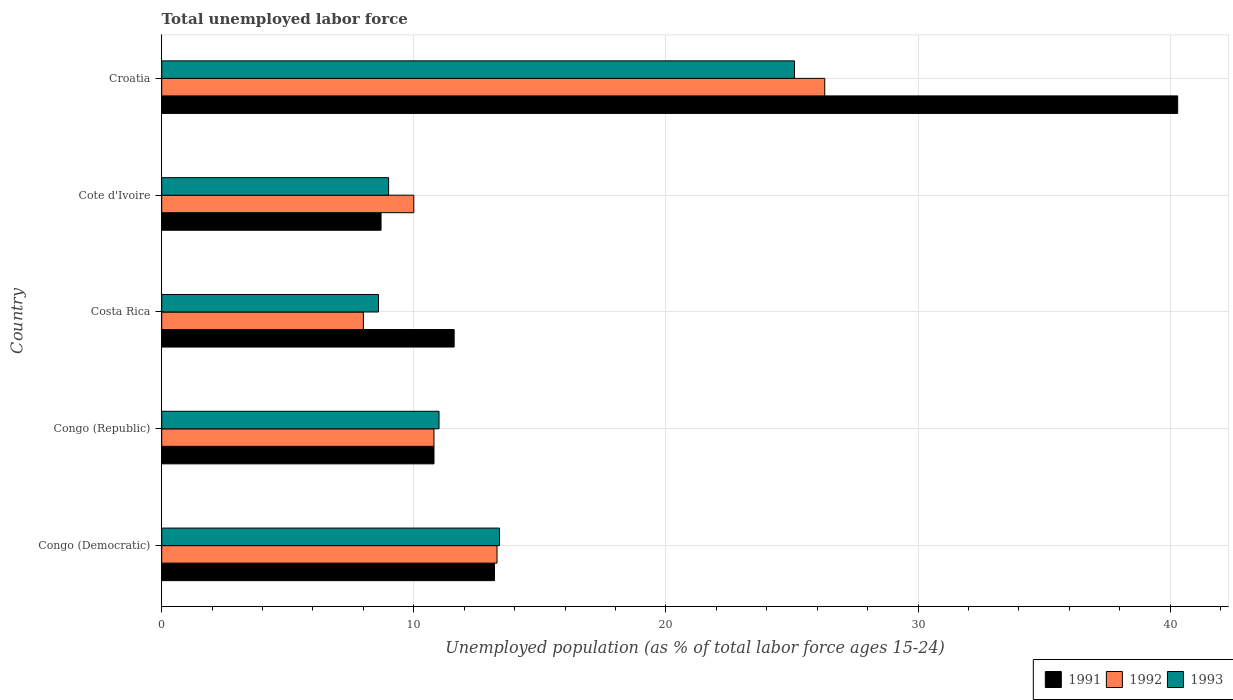How many different coloured bars are there?
Offer a terse response. 3. Are the number of bars on each tick of the Y-axis equal?
Keep it short and to the point. Yes. How many bars are there on the 4th tick from the top?
Your response must be concise. 3. How many bars are there on the 2nd tick from the bottom?
Ensure brevity in your answer.  3. What is the label of the 4th group of bars from the top?
Give a very brief answer. Congo (Republic). In how many cases, is the number of bars for a given country not equal to the number of legend labels?
Your answer should be very brief. 0. What is the percentage of unemployed population in in 1992 in Congo (Republic)?
Make the answer very short. 10.8. Across all countries, what is the maximum percentage of unemployed population in in 1992?
Your answer should be compact. 26.3. Across all countries, what is the minimum percentage of unemployed population in in 1992?
Keep it short and to the point. 8. In which country was the percentage of unemployed population in in 1993 maximum?
Provide a succinct answer. Croatia. In which country was the percentage of unemployed population in in 1991 minimum?
Your answer should be very brief. Cote d'Ivoire. What is the total percentage of unemployed population in in 1991 in the graph?
Make the answer very short. 84.6. What is the difference between the percentage of unemployed population in in 1992 in Costa Rica and that in Croatia?
Give a very brief answer. -18.3. What is the difference between the percentage of unemployed population in in 1991 in Cote d'Ivoire and the percentage of unemployed population in in 1993 in Congo (Democratic)?
Offer a very short reply. -4.7. What is the average percentage of unemployed population in in 1992 per country?
Offer a terse response. 13.68. What is the difference between the percentage of unemployed population in in 1991 and percentage of unemployed population in in 1992 in Congo (Democratic)?
Ensure brevity in your answer.  -0.1. What is the ratio of the percentage of unemployed population in in 1992 in Congo (Republic) to that in Cote d'Ivoire?
Your answer should be compact. 1.08. Is the percentage of unemployed population in in 1992 in Congo (Democratic) less than that in Cote d'Ivoire?
Give a very brief answer. No. What is the difference between the highest and the second highest percentage of unemployed population in in 1992?
Your answer should be very brief. 13. What is the difference between the highest and the lowest percentage of unemployed population in in 1993?
Your answer should be compact. 16.5. What does the 2nd bar from the bottom in Croatia represents?
Offer a terse response. 1992. What is the difference between two consecutive major ticks on the X-axis?
Provide a short and direct response. 10. Are the values on the major ticks of X-axis written in scientific E-notation?
Your answer should be compact. No. Where does the legend appear in the graph?
Your answer should be very brief. Bottom right. What is the title of the graph?
Provide a short and direct response. Total unemployed labor force. Does "2013" appear as one of the legend labels in the graph?
Your answer should be very brief. No. What is the label or title of the X-axis?
Your answer should be compact. Unemployed population (as % of total labor force ages 15-24). What is the label or title of the Y-axis?
Offer a terse response. Country. What is the Unemployed population (as % of total labor force ages 15-24) in 1991 in Congo (Democratic)?
Provide a succinct answer. 13.2. What is the Unemployed population (as % of total labor force ages 15-24) of 1992 in Congo (Democratic)?
Your response must be concise. 13.3. What is the Unemployed population (as % of total labor force ages 15-24) of 1993 in Congo (Democratic)?
Provide a succinct answer. 13.4. What is the Unemployed population (as % of total labor force ages 15-24) of 1991 in Congo (Republic)?
Your answer should be very brief. 10.8. What is the Unemployed population (as % of total labor force ages 15-24) in 1992 in Congo (Republic)?
Your answer should be very brief. 10.8. What is the Unemployed population (as % of total labor force ages 15-24) in 1991 in Costa Rica?
Your answer should be very brief. 11.6. What is the Unemployed population (as % of total labor force ages 15-24) in 1992 in Costa Rica?
Give a very brief answer. 8. What is the Unemployed population (as % of total labor force ages 15-24) in 1993 in Costa Rica?
Keep it short and to the point. 8.6. What is the Unemployed population (as % of total labor force ages 15-24) of 1991 in Cote d'Ivoire?
Provide a succinct answer. 8.7. What is the Unemployed population (as % of total labor force ages 15-24) in 1991 in Croatia?
Give a very brief answer. 40.3. What is the Unemployed population (as % of total labor force ages 15-24) of 1992 in Croatia?
Provide a succinct answer. 26.3. What is the Unemployed population (as % of total labor force ages 15-24) in 1993 in Croatia?
Make the answer very short. 25.1. Across all countries, what is the maximum Unemployed population (as % of total labor force ages 15-24) of 1991?
Ensure brevity in your answer.  40.3. Across all countries, what is the maximum Unemployed population (as % of total labor force ages 15-24) in 1992?
Give a very brief answer. 26.3. Across all countries, what is the maximum Unemployed population (as % of total labor force ages 15-24) of 1993?
Ensure brevity in your answer.  25.1. Across all countries, what is the minimum Unemployed population (as % of total labor force ages 15-24) of 1991?
Your answer should be very brief. 8.7. Across all countries, what is the minimum Unemployed population (as % of total labor force ages 15-24) in 1993?
Offer a terse response. 8.6. What is the total Unemployed population (as % of total labor force ages 15-24) of 1991 in the graph?
Provide a succinct answer. 84.6. What is the total Unemployed population (as % of total labor force ages 15-24) of 1992 in the graph?
Your response must be concise. 68.4. What is the total Unemployed population (as % of total labor force ages 15-24) of 1993 in the graph?
Your answer should be very brief. 67.1. What is the difference between the Unemployed population (as % of total labor force ages 15-24) of 1992 in Congo (Democratic) and that in Congo (Republic)?
Keep it short and to the point. 2.5. What is the difference between the Unemployed population (as % of total labor force ages 15-24) of 1991 in Congo (Democratic) and that in Costa Rica?
Ensure brevity in your answer.  1.6. What is the difference between the Unemployed population (as % of total labor force ages 15-24) of 1992 in Congo (Democratic) and that in Cote d'Ivoire?
Your answer should be very brief. 3.3. What is the difference between the Unemployed population (as % of total labor force ages 15-24) of 1991 in Congo (Democratic) and that in Croatia?
Ensure brevity in your answer.  -27.1. What is the difference between the Unemployed population (as % of total labor force ages 15-24) of 1992 in Congo (Democratic) and that in Croatia?
Give a very brief answer. -13. What is the difference between the Unemployed population (as % of total labor force ages 15-24) in 1991 in Congo (Republic) and that in Costa Rica?
Make the answer very short. -0.8. What is the difference between the Unemployed population (as % of total labor force ages 15-24) in 1992 in Congo (Republic) and that in Costa Rica?
Your response must be concise. 2.8. What is the difference between the Unemployed population (as % of total labor force ages 15-24) of 1992 in Congo (Republic) and that in Cote d'Ivoire?
Your response must be concise. 0.8. What is the difference between the Unemployed population (as % of total labor force ages 15-24) in 1993 in Congo (Republic) and that in Cote d'Ivoire?
Your answer should be compact. 2. What is the difference between the Unemployed population (as % of total labor force ages 15-24) in 1991 in Congo (Republic) and that in Croatia?
Offer a terse response. -29.5. What is the difference between the Unemployed population (as % of total labor force ages 15-24) in 1992 in Congo (Republic) and that in Croatia?
Offer a very short reply. -15.5. What is the difference between the Unemployed population (as % of total labor force ages 15-24) in 1993 in Congo (Republic) and that in Croatia?
Offer a terse response. -14.1. What is the difference between the Unemployed population (as % of total labor force ages 15-24) in 1991 in Costa Rica and that in Cote d'Ivoire?
Your response must be concise. 2.9. What is the difference between the Unemployed population (as % of total labor force ages 15-24) in 1993 in Costa Rica and that in Cote d'Ivoire?
Your answer should be very brief. -0.4. What is the difference between the Unemployed population (as % of total labor force ages 15-24) in 1991 in Costa Rica and that in Croatia?
Offer a very short reply. -28.7. What is the difference between the Unemployed population (as % of total labor force ages 15-24) in 1992 in Costa Rica and that in Croatia?
Give a very brief answer. -18.3. What is the difference between the Unemployed population (as % of total labor force ages 15-24) in 1993 in Costa Rica and that in Croatia?
Give a very brief answer. -16.5. What is the difference between the Unemployed population (as % of total labor force ages 15-24) of 1991 in Cote d'Ivoire and that in Croatia?
Ensure brevity in your answer.  -31.6. What is the difference between the Unemployed population (as % of total labor force ages 15-24) in 1992 in Cote d'Ivoire and that in Croatia?
Your answer should be compact. -16.3. What is the difference between the Unemployed population (as % of total labor force ages 15-24) of 1993 in Cote d'Ivoire and that in Croatia?
Provide a short and direct response. -16.1. What is the difference between the Unemployed population (as % of total labor force ages 15-24) in 1991 in Congo (Democratic) and the Unemployed population (as % of total labor force ages 15-24) in 1992 in Congo (Republic)?
Keep it short and to the point. 2.4. What is the difference between the Unemployed population (as % of total labor force ages 15-24) in 1991 in Congo (Democratic) and the Unemployed population (as % of total labor force ages 15-24) in 1993 in Congo (Republic)?
Provide a short and direct response. 2.2. What is the difference between the Unemployed population (as % of total labor force ages 15-24) of 1992 in Congo (Democratic) and the Unemployed population (as % of total labor force ages 15-24) of 1993 in Congo (Republic)?
Keep it short and to the point. 2.3. What is the difference between the Unemployed population (as % of total labor force ages 15-24) in 1991 in Congo (Democratic) and the Unemployed population (as % of total labor force ages 15-24) in 1992 in Cote d'Ivoire?
Your answer should be very brief. 3.2. What is the difference between the Unemployed population (as % of total labor force ages 15-24) in 1991 in Congo (Democratic) and the Unemployed population (as % of total labor force ages 15-24) in 1993 in Cote d'Ivoire?
Your answer should be very brief. 4.2. What is the difference between the Unemployed population (as % of total labor force ages 15-24) of 1991 in Congo (Democratic) and the Unemployed population (as % of total labor force ages 15-24) of 1992 in Croatia?
Ensure brevity in your answer.  -13.1. What is the difference between the Unemployed population (as % of total labor force ages 15-24) in 1992 in Congo (Democratic) and the Unemployed population (as % of total labor force ages 15-24) in 1993 in Croatia?
Provide a short and direct response. -11.8. What is the difference between the Unemployed population (as % of total labor force ages 15-24) in 1991 in Congo (Republic) and the Unemployed population (as % of total labor force ages 15-24) in 1992 in Costa Rica?
Offer a very short reply. 2.8. What is the difference between the Unemployed population (as % of total labor force ages 15-24) in 1991 in Congo (Republic) and the Unemployed population (as % of total labor force ages 15-24) in 1992 in Cote d'Ivoire?
Make the answer very short. 0.8. What is the difference between the Unemployed population (as % of total labor force ages 15-24) of 1992 in Congo (Republic) and the Unemployed population (as % of total labor force ages 15-24) of 1993 in Cote d'Ivoire?
Make the answer very short. 1.8. What is the difference between the Unemployed population (as % of total labor force ages 15-24) in 1991 in Congo (Republic) and the Unemployed population (as % of total labor force ages 15-24) in 1992 in Croatia?
Your response must be concise. -15.5. What is the difference between the Unemployed population (as % of total labor force ages 15-24) in 1991 in Congo (Republic) and the Unemployed population (as % of total labor force ages 15-24) in 1993 in Croatia?
Make the answer very short. -14.3. What is the difference between the Unemployed population (as % of total labor force ages 15-24) in 1992 in Congo (Republic) and the Unemployed population (as % of total labor force ages 15-24) in 1993 in Croatia?
Offer a terse response. -14.3. What is the difference between the Unemployed population (as % of total labor force ages 15-24) of 1991 in Costa Rica and the Unemployed population (as % of total labor force ages 15-24) of 1992 in Cote d'Ivoire?
Ensure brevity in your answer.  1.6. What is the difference between the Unemployed population (as % of total labor force ages 15-24) of 1991 in Costa Rica and the Unemployed population (as % of total labor force ages 15-24) of 1992 in Croatia?
Your answer should be compact. -14.7. What is the difference between the Unemployed population (as % of total labor force ages 15-24) in 1991 in Costa Rica and the Unemployed population (as % of total labor force ages 15-24) in 1993 in Croatia?
Your response must be concise. -13.5. What is the difference between the Unemployed population (as % of total labor force ages 15-24) in 1992 in Costa Rica and the Unemployed population (as % of total labor force ages 15-24) in 1993 in Croatia?
Your response must be concise. -17.1. What is the difference between the Unemployed population (as % of total labor force ages 15-24) of 1991 in Cote d'Ivoire and the Unemployed population (as % of total labor force ages 15-24) of 1992 in Croatia?
Ensure brevity in your answer.  -17.6. What is the difference between the Unemployed population (as % of total labor force ages 15-24) of 1991 in Cote d'Ivoire and the Unemployed population (as % of total labor force ages 15-24) of 1993 in Croatia?
Keep it short and to the point. -16.4. What is the difference between the Unemployed population (as % of total labor force ages 15-24) of 1992 in Cote d'Ivoire and the Unemployed population (as % of total labor force ages 15-24) of 1993 in Croatia?
Offer a terse response. -15.1. What is the average Unemployed population (as % of total labor force ages 15-24) in 1991 per country?
Offer a terse response. 16.92. What is the average Unemployed population (as % of total labor force ages 15-24) in 1992 per country?
Your answer should be compact. 13.68. What is the average Unemployed population (as % of total labor force ages 15-24) of 1993 per country?
Keep it short and to the point. 13.42. What is the difference between the Unemployed population (as % of total labor force ages 15-24) in 1991 and Unemployed population (as % of total labor force ages 15-24) in 1992 in Congo (Democratic)?
Provide a succinct answer. -0.1. What is the difference between the Unemployed population (as % of total labor force ages 15-24) in 1991 and Unemployed population (as % of total labor force ages 15-24) in 1993 in Congo (Democratic)?
Your answer should be very brief. -0.2. What is the difference between the Unemployed population (as % of total labor force ages 15-24) of 1992 and Unemployed population (as % of total labor force ages 15-24) of 1993 in Congo (Democratic)?
Offer a terse response. -0.1. What is the difference between the Unemployed population (as % of total labor force ages 15-24) of 1991 and Unemployed population (as % of total labor force ages 15-24) of 1992 in Congo (Republic)?
Offer a terse response. 0. What is the difference between the Unemployed population (as % of total labor force ages 15-24) of 1991 and Unemployed population (as % of total labor force ages 15-24) of 1993 in Congo (Republic)?
Give a very brief answer. -0.2. What is the difference between the Unemployed population (as % of total labor force ages 15-24) in 1991 and Unemployed population (as % of total labor force ages 15-24) in 1993 in Costa Rica?
Your answer should be compact. 3. What is the difference between the Unemployed population (as % of total labor force ages 15-24) in 1992 and Unemployed population (as % of total labor force ages 15-24) in 1993 in Costa Rica?
Provide a succinct answer. -0.6. What is the difference between the Unemployed population (as % of total labor force ages 15-24) of 1991 and Unemployed population (as % of total labor force ages 15-24) of 1992 in Cote d'Ivoire?
Your answer should be very brief. -1.3. What is the difference between the Unemployed population (as % of total labor force ages 15-24) of 1991 and Unemployed population (as % of total labor force ages 15-24) of 1993 in Cote d'Ivoire?
Offer a terse response. -0.3. What is the difference between the Unemployed population (as % of total labor force ages 15-24) of 1991 and Unemployed population (as % of total labor force ages 15-24) of 1993 in Croatia?
Provide a succinct answer. 15.2. What is the ratio of the Unemployed population (as % of total labor force ages 15-24) in 1991 in Congo (Democratic) to that in Congo (Republic)?
Offer a very short reply. 1.22. What is the ratio of the Unemployed population (as % of total labor force ages 15-24) of 1992 in Congo (Democratic) to that in Congo (Republic)?
Keep it short and to the point. 1.23. What is the ratio of the Unemployed population (as % of total labor force ages 15-24) of 1993 in Congo (Democratic) to that in Congo (Republic)?
Give a very brief answer. 1.22. What is the ratio of the Unemployed population (as % of total labor force ages 15-24) of 1991 in Congo (Democratic) to that in Costa Rica?
Offer a terse response. 1.14. What is the ratio of the Unemployed population (as % of total labor force ages 15-24) of 1992 in Congo (Democratic) to that in Costa Rica?
Your answer should be compact. 1.66. What is the ratio of the Unemployed population (as % of total labor force ages 15-24) in 1993 in Congo (Democratic) to that in Costa Rica?
Provide a succinct answer. 1.56. What is the ratio of the Unemployed population (as % of total labor force ages 15-24) of 1991 in Congo (Democratic) to that in Cote d'Ivoire?
Offer a very short reply. 1.52. What is the ratio of the Unemployed population (as % of total labor force ages 15-24) in 1992 in Congo (Democratic) to that in Cote d'Ivoire?
Provide a succinct answer. 1.33. What is the ratio of the Unemployed population (as % of total labor force ages 15-24) in 1993 in Congo (Democratic) to that in Cote d'Ivoire?
Offer a terse response. 1.49. What is the ratio of the Unemployed population (as % of total labor force ages 15-24) in 1991 in Congo (Democratic) to that in Croatia?
Make the answer very short. 0.33. What is the ratio of the Unemployed population (as % of total labor force ages 15-24) in 1992 in Congo (Democratic) to that in Croatia?
Give a very brief answer. 0.51. What is the ratio of the Unemployed population (as % of total labor force ages 15-24) in 1993 in Congo (Democratic) to that in Croatia?
Make the answer very short. 0.53. What is the ratio of the Unemployed population (as % of total labor force ages 15-24) of 1992 in Congo (Republic) to that in Costa Rica?
Provide a short and direct response. 1.35. What is the ratio of the Unemployed population (as % of total labor force ages 15-24) of 1993 in Congo (Republic) to that in Costa Rica?
Ensure brevity in your answer.  1.28. What is the ratio of the Unemployed population (as % of total labor force ages 15-24) of 1991 in Congo (Republic) to that in Cote d'Ivoire?
Your answer should be compact. 1.24. What is the ratio of the Unemployed population (as % of total labor force ages 15-24) in 1993 in Congo (Republic) to that in Cote d'Ivoire?
Your answer should be compact. 1.22. What is the ratio of the Unemployed population (as % of total labor force ages 15-24) of 1991 in Congo (Republic) to that in Croatia?
Offer a terse response. 0.27. What is the ratio of the Unemployed population (as % of total labor force ages 15-24) of 1992 in Congo (Republic) to that in Croatia?
Your answer should be compact. 0.41. What is the ratio of the Unemployed population (as % of total labor force ages 15-24) in 1993 in Congo (Republic) to that in Croatia?
Keep it short and to the point. 0.44. What is the ratio of the Unemployed population (as % of total labor force ages 15-24) of 1991 in Costa Rica to that in Cote d'Ivoire?
Ensure brevity in your answer.  1.33. What is the ratio of the Unemployed population (as % of total labor force ages 15-24) of 1992 in Costa Rica to that in Cote d'Ivoire?
Offer a very short reply. 0.8. What is the ratio of the Unemployed population (as % of total labor force ages 15-24) in 1993 in Costa Rica to that in Cote d'Ivoire?
Give a very brief answer. 0.96. What is the ratio of the Unemployed population (as % of total labor force ages 15-24) in 1991 in Costa Rica to that in Croatia?
Your response must be concise. 0.29. What is the ratio of the Unemployed population (as % of total labor force ages 15-24) in 1992 in Costa Rica to that in Croatia?
Offer a very short reply. 0.3. What is the ratio of the Unemployed population (as % of total labor force ages 15-24) of 1993 in Costa Rica to that in Croatia?
Offer a terse response. 0.34. What is the ratio of the Unemployed population (as % of total labor force ages 15-24) of 1991 in Cote d'Ivoire to that in Croatia?
Make the answer very short. 0.22. What is the ratio of the Unemployed population (as % of total labor force ages 15-24) in 1992 in Cote d'Ivoire to that in Croatia?
Ensure brevity in your answer.  0.38. What is the ratio of the Unemployed population (as % of total labor force ages 15-24) in 1993 in Cote d'Ivoire to that in Croatia?
Provide a succinct answer. 0.36. What is the difference between the highest and the second highest Unemployed population (as % of total labor force ages 15-24) in 1991?
Ensure brevity in your answer.  27.1. What is the difference between the highest and the second highest Unemployed population (as % of total labor force ages 15-24) of 1992?
Give a very brief answer. 13. What is the difference between the highest and the second highest Unemployed population (as % of total labor force ages 15-24) in 1993?
Offer a very short reply. 11.7. What is the difference between the highest and the lowest Unemployed population (as % of total labor force ages 15-24) of 1991?
Give a very brief answer. 31.6. 